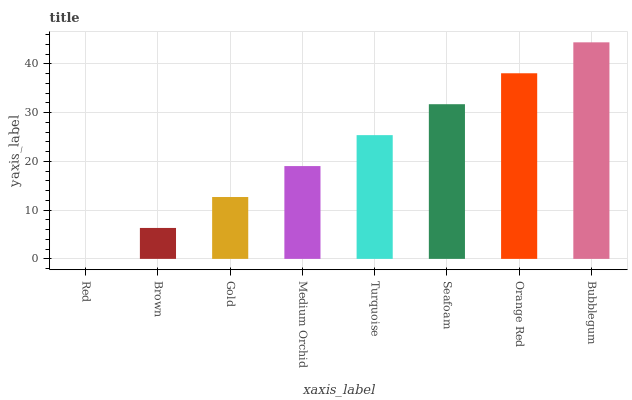Is Red the minimum?
Answer yes or no. Yes. Is Bubblegum the maximum?
Answer yes or no. Yes. Is Brown the minimum?
Answer yes or no. No. Is Brown the maximum?
Answer yes or no. No. Is Brown greater than Red?
Answer yes or no. Yes. Is Red less than Brown?
Answer yes or no. Yes. Is Red greater than Brown?
Answer yes or no. No. Is Brown less than Red?
Answer yes or no. No. Is Turquoise the high median?
Answer yes or no. Yes. Is Medium Orchid the low median?
Answer yes or no. Yes. Is Red the high median?
Answer yes or no. No. Is Red the low median?
Answer yes or no. No. 